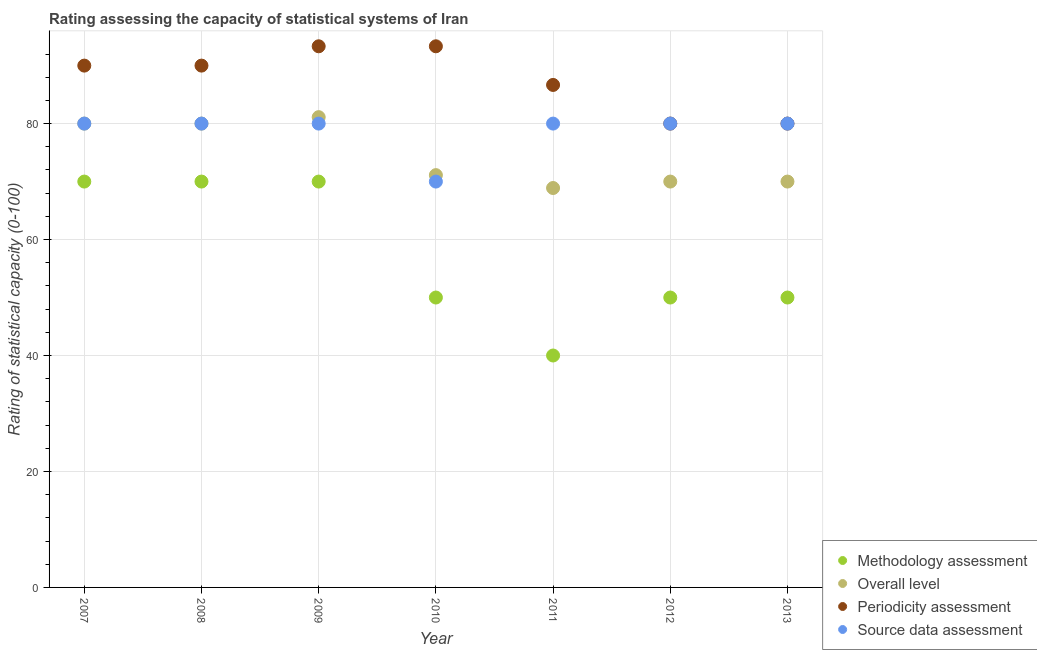How many different coloured dotlines are there?
Provide a succinct answer. 4. Is the number of dotlines equal to the number of legend labels?
Your answer should be very brief. Yes. Across all years, what is the maximum overall level rating?
Your answer should be very brief. 81.11. Across all years, what is the minimum overall level rating?
Make the answer very short. 68.89. In which year was the periodicity assessment rating minimum?
Ensure brevity in your answer.  2012. What is the total methodology assessment rating in the graph?
Provide a short and direct response. 400. What is the difference between the periodicity assessment rating in 2007 and that in 2010?
Give a very brief answer. -3.33. What is the difference between the overall level rating in 2011 and the source data assessment rating in 2008?
Your response must be concise. -11.11. What is the average overall level rating per year?
Offer a terse response. 74.44. In the year 2009, what is the difference between the source data assessment rating and overall level rating?
Your answer should be very brief. -1.11. What is the ratio of the source data assessment rating in 2010 to that in 2011?
Offer a terse response. 0.88. Is the methodology assessment rating in 2009 less than that in 2012?
Keep it short and to the point. No. What is the difference between the highest and the lowest overall level rating?
Your answer should be compact. 12.22. In how many years, is the methodology assessment rating greater than the average methodology assessment rating taken over all years?
Your response must be concise. 3. Is the sum of the periodicity assessment rating in 2008 and 2011 greater than the maximum source data assessment rating across all years?
Your answer should be compact. Yes. Is the overall level rating strictly greater than the source data assessment rating over the years?
Provide a short and direct response. No. Are the values on the major ticks of Y-axis written in scientific E-notation?
Your answer should be compact. No. Does the graph contain grids?
Ensure brevity in your answer.  Yes. How are the legend labels stacked?
Give a very brief answer. Vertical. What is the title of the graph?
Offer a very short reply. Rating assessing the capacity of statistical systems of Iran. Does "Subsidies and Transfers" appear as one of the legend labels in the graph?
Give a very brief answer. No. What is the label or title of the X-axis?
Give a very brief answer. Year. What is the label or title of the Y-axis?
Give a very brief answer. Rating of statistical capacity (0-100). What is the Rating of statistical capacity (0-100) in Periodicity assessment in 2007?
Offer a terse response. 90. What is the Rating of statistical capacity (0-100) of Source data assessment in 2007?
Your response must be concise. 80. What is the Rating of statistical capacity (0-100) of Methodology assessment in 2008?
Your response must be concise. 70. What is the Rating of statistical capacity (0-100) of Methodology assessment in 2009?
Offer a terse response. 70. What is the Rating of statistical capacity (0-100) in Overall level in 2009?
Provide a succinct answer. 81.11. What is the Rating of statistical capacity (0-100) in Periodicity assessment in 2009?
Your answer should be compact. 93.33. What is the Rating of statistical capacity (0-100) in Source data assessment in 2009?
Offer a terse response. 80. What is the Rating of statistical capacity (0-100) in Overall level in 2010?
Offer a very short reply. 71.11. What is the Rating of statistical capacity (0-100) in Periodicity assessment in 2010?
Provide a succinct answer. 93.33. What is the Rating of statistical capacity (0-100) of Source data assessment in 2010?
Your response must be concise. 70. What is the Rating of statistical capacity (0-100) of Methodology assessment in 2011?
Give a very brief answer. 40. What is the Rating of statistical capacity (0-100) of Overall level in 2011?
Offer a terse response. 68.89. What is the Rating of statistical capacity (0-100) of Periodicity assessment in 2011?
Keep it short and to the point. 86.67. What is the Rating of statistical capacity (0-100) in Overall level in 2012?
Your answer should be compact. 70. What is the Rating of statistical capacity (0-100) of Periodicity assessment in 2012?
Your answer should be very brief. 80. What is the Rating of statistical capacity (0-100) of Source data assessment in 2012?
Provide a succinct answer. 80. What is the Rating of statistical capacity (0-100) of Periodicity assessment in 2013?
Your answer should be very brief. 80. What is the Rating of statistical capacity (0-100) of Source data assessment in 2013?
Provide a short and direct response. 80. Across all years, what is the maximum Rating of statistical capacity (0-100) in Overall level?
Ensure brevity in your answer.  81.11. Across all years, what is the maximum Rating of statistical capacity (0-100) in Periodicity assessment?
Make the answer very short. 93.33. Across all years, what is the maximum Rating of statistical capacity (0-100) of Source data assessment?
Provide a short and direct response. 80. Across all years, what is the minimum Rating of statistical capacity (0-100) in Methodology assessment?
Make the answer very short. 40. Across all years, what is the minimum Rating of statistical capacity (0-100) of Overall level?
Your answer should be very brief. 68.89. Across all years, what is the minimum Rating of statistical capacity (0-100) of Periodicity assessment?
Ensure brevity in your answer.  80. What is the total Rating of statistical capacity (0-100) in Methodology assessment in the graph?
Your response must be concise. 400. What is the total Rating of statistical capacity (0-100) of Overall level in the graph?
Your response must be concise. 521.11. What is the total Rating of statistical capacity (0-100) of Periodicity assessment in the graph?
Your answer should be very brief. 613.33. What is the total Rating of statistical capacity (0-100) in Source data assessment in the graph?
Provide a short and direct response. 550. What is the difference between the Rating of statistical capacity (0-100) in Methodology assessment in 2007 and that in 2008?
Offer a terse response. 0. What is the difference between the Rating of statistical capacity (0-100) in Source data assessment in 2007 and that in 2008?
Make the answer very short. 0. What is the difference between the Rating of statistical capacity (0-100) in Overall level in 2007 and that in 2009?
Provide a short and direct response. -1.11. What is the difference between the Rating of statistical capacity (0-100) in Methodology assessment in 2007 and that in 2010?
Make the answer very short. 20. What is the difference between the Rating of statistical capacity (0-100) in Overall level in 2007 and that in 2010?
Offer a terse response. 8.89. What is the difference between the Rating of statistical capacity (0-100) of Periodicity assessment in 2007 and that in 2010?
Your response must be concise. -3.33. What is the difference between the Rating of statistical capacity (0-100) in Source data assessment in 2007 and that in 2010?
Your answer should be compact. 10. What is the difference between the Rating of statistical capacity (0-100) in Overall level in 2007 and that in 2011?
Offer a very short reply. 11.11. What is the difference between the Rating of statistical capacity (0-100) of Periodicity assessment in 2007 and that in 2011?
Provide a short and direct response. 3.33. What is the difference between the Rating of statistical capacity (0-100) in Methodology assessment in 2007 and that in 2012?
Offer a very short reply. 20. What is the difference between the Rating of statistical capacity (0-100) of Periodicity assessment in 2007 and that in 2012?
Ensure brevity in your answer.  10. What is the difference between the Rating of statistical capacity (0-100) of Source data assessment in 2007 and that in 2012?
Your response must be concise. 0. What is the difference between the Rating of statistical capacity (0-100) of Overall level in 2007 and that in 2013?
Provide a short and direct response. 10. What is the difference between the Rating of statistical capacity (0-100) of Source data assessment in 2007 and that in 2013?
Your response must be concise. 0. What is the difference between the Rating of statistical capacity (0-100) of Methodology assessment in 2008 and that in 2009?
Provide a succinct answer. 0. What is the difference between the Rating of statistical capacity (0-100) in Overall level in 2008 and that in 2009?
Your response must be concise. -1.11. What is the difference between the Rating of statistical capacity (0-100) of Periodicity assessment in 2008 and that in 2009?
Your answer should be compact. -3.33. What is the difference between the Rating of statistical capacity (0-100) in Source data assessment in 2008 and that in 2009?
Ensure brevity in your answer.  0. What is the difference between the Rating of statistical capacity (0-100) in Methodology assessment in 2008 and that in 2010?
Provide a succinct answer. 20. What is the difference between the Rating of statistical capacity (0-100) of Overall level in 2008 and that in 2010?
Ensure brevity in your answer.  8.89. What is the difference between the Rating of statistical capacity (0-100) in Periodicity assessment in 2008 and that in 2010?
Your response must be concise. -3.33. What is the difference between the Rating of statistical capacity (0-100) in Source data assessment in 2008 and that in 2010?
Your response must be concise. 10. What is the difference between the Rating of statistical capacity (0-100) of Methodology assessment in 2008 and that in 2011?
Make the answer very short. 30. What is the difference between the Rating of statistical capacity (0-100) in Overall level in 2008 and that in 2011?
Give a very brief answer. 11.11. What is the difference between the Rating of statistical capacity (0-100) in Source data assessment in 2008 and that in 2011?
Your answer should be very brief. 0. What is the difference between the Rating of statistical capacity (0-100) of Overall level in 2008 and that in 2012?
Ensure brevity in your answer.  10. What is the difference between the Rating of statistical capacity (0-100) of Source data assessment in 2008 and that in 2012?
Ensure brevity in your answer.  0. What is the difference between the Rating of statistical capacity (0-100) in Periodicity assessment in 2008 and that in 2013?
Keep it short and to the point. 10. What is the difference between the Rating of statistical capacity (0-100) of Source data assessment in 2008 and that in 2013?
Keep it short and to the point. 0. What is the difference between the Rating of statistical capacity (0-100) in Methodology assessment in 2009 and that in 2010?
Your response must be concise. 20. What is the difference between the Rating of statistical capacity (0-100) in Overall level in 2009 and that in 2010?
Provide a short and direct response. 10. What is the difference between the Rating of statistical capacity (0-100) in Periodicity assessment in 2009 and that in 2010?
Ensure brevity in your answer.  0. What is the difference between the Rating of statistical capacity (0-100) in Methodology assessment in 2009 and that in 2011?
Give a very brief answer. 30. What is the difference between the Rating of statistical capacity (0-100) in Overall level in 2009 and that in 2011?
Your answer should be compact. 12.22. What is the difference between the Rating of statistical capacity (0-100) in Periodicity assessment in 2009 and that in 2011?
Make the answer very short. 6.67. What is the difference between the Rating of statistical capacity (0-100) of Overall level in 2009 and that in 2012?
Your answer should be very brief. 11.11. What is the difference between the Rating of statistical capacity (0-100) in Periodicity assessment in 2009 and that in 2012?
Your answer should be very brief. 13.33. What is the difference between the Rating of statistical capacity (0-100) of Methodology assessment in 2009 and that in 2013?
Provide a short and direct response. 20. What is the difference between the Rating of statistical capacity (0-100) of Overall level in 2009 and that in 2013?
Provide a short and direct response. 11.11. What is the difference between the Rating of statistical capacity (0-100) of Periodicity assessment in 2009 and that in 2013?
Your answer should be compact. 13.33. What is the difference between the Rating of statistical capacity (0-100) in Methodology assessment in 2010 and that in 2011?
Provide a short and direct response. 10. What is the difference between the Rating of statistical capacity (0-100) in Overall level in 2010 and that in 2011?
Your response must be concise. 2.22. What is the difference between the Rating of statistical capacity (0-100) in Source data assessment in 2010 and that in 2011?
Ensure brevity in your answer.  -10. What is the difference between the Rating of statistical capacity (0-100) of Overall level in 2010 and that in 2012?
Make the answer very short. 1.11. What is the difference between the Rating of statistical capacity (0-100) in Periodicity assessment in 2010 and that in 2012?
Your response must be concise. 13.33. What is the difference between the Rating of statistical capacity (0-100) of Overall level in 2010 and that in 2013?
Offer a terse response. 1.11. What is the difference between the Rating of statistical capacity (0-100) of Periodicity assessment in 2010 and that in 2013?
Ensure brevity in your answer.  13.33. What is the difference between the Rating of statistical capacity (0-100) in Source data assessment in 2010 and that in 2013?
Your answer should be very brief. -10. What is the difference between the Rating of statistical capacity (0-100) of Methodology assessment in 2011 and that in 2012?
Ensure brevity in your answer.  -10. What is the difference between the Rating of statistical capacity (0-100) in Overall level in 2011 and that in 2012?
Provide a short and direct response. -1.11. What is the difference between the Rating of statistical capacity (0-100) in Methodology assessment in 2011 and that in 2013?
Your answer should be compact. -10. What is the difference between the Rating of statistical capacity (0-100) in Overall level in 2011 and that in 2013?
Give a very brief answer. -1.11. What is the difference between the Rating of statistical capacity (0-100) of Source data assessment in 2012 and that in 2013?
Provide a succinct answer. 0. What is the difference between the Rating of statistical capacity (0-100) of Methodology assessment in 2007 and the Rating of statistical capacity (0-100) of Overall level in 2008?
Provide a short and direct response. -10. What is the difference between the Rating of statistical capacity (0-100) in Methodology assessment in 2007 and the Rating of statistical capacity (0-100) in Periodicity assessment in 2008?
Offer a terse response. -20. What is the difference between the Rating of statistical capacity (0-100) in Methodology assessment in 2007 and the Rating of statistical capacity (0-100) in Source data assessment in 2008?
Make the answer very short. -10. What is the difference between the Rating of statistical capacity (0-100) of Overall level in 2007 and the Rating of statistical capacity (0-100) of Periodicity assessment in 2008?
Ensure brevity in your answer.  -10. What is the difference between the Rating of statistical capacity (0-100) in Methodology assessment in 2007 and the Rating of statistical capacity (0-100) in Overall level in 2009?
Your answer should be very brief. -11.11. What is the difference between the Rating of statistical capacity (0-100) in Methodology assessment in 2007 and the Rating of statistical capacity (0-100) in Periodicity assessment in 2009?
Provide a succinct answer. -23.33. What is the difference between the Rating of statistical capacity (0-100) of Overall level in 2007 and the Rating of statistical capacity (0-100) of Periodicity assessment in 2009?
Provide a short and direct response. -13.33. What is the difference between the Rating of statistical capacity (0-100) in Overall level in 2007 and the Rating of statistical capacity (0-100) in Source data assessment in 2009?
Provide a succinct answer. 0. What is the difference between the Rating of statistical capacity (0-100) of Methodology assessment in 2007 and the Rating of statistical capacity (0-100) of Overall level in 2010?
Ensure brevity in your answer.  -1.11. What is the difference between the Rating of statistical capacity (0-100) of Methodology assessment in 2007 and the Rating of statistical capacity (0-100) of Periodicity assessment in 2010?
Your answer should be very brief. -23.33. What is the difference between the Rating of statistical capacity (0-100) in Overall level in 2007 and the Rating of statistical capacity (0-100) in Periodicity assessment in 2010?
Your response must be concise. -13.33. What is the difference between the Rating of statistical capacity (0-100) of Periodicity assessment in 2007 and the Rating of statistical capacity (0-100) of Source data assessment in 2010?
Keep it short and to the point. 20. What is the difference between the Rating of statistical capacity (0-100) of Methodology assessment in 2007 and the Rating of statistical capacity (0-100) of Overall level in 2011?
Your response must be concise. 1.11. What is the difference between the Rating of statistical capacity (0-100) of Methodology assessment in 2007 and the Rating of statistical capacity (0-100) of Periodicity assessment in 2011?
Keep it short and to the point. -16.67. What is the difference between the Rating of statistical capacity (0-100) of Methodology assessment in 2007 and the Rating of statistical capacity (0-100) of Source data assessment in 2011?
Offer a terse response. -10. What is the difference between the Rating of statistical capacity (0-100) of Overall level in 2007 and the Rating of statistical capacity (0-100) of Periodicity assessment in 2011?
Ensure brevity in your answer.  -6.67. What is the difference between the Rating of statistical capacity (0-100) of Overall level in 2007 and the Rating of statistical capacity (0-100) of Source data assessment in 2011?
Provide a short and direct response. 0. What is the difference between the Rating of statistical capacity (0-100) in Methodology assessment in 2007 and the Rating of statistical capacity (0-100) in Source data assessment in 2012?
Make the answer very short. -10. What is the difference between the Rating of statistical capacity (0-100) of Overall level in 2007 and the Rating of statistical capacity (0-100) of Periodicity assessment in 2012?
Your response must be concise. 0. What is the difference between the Rating of statistical capacity (0-100) of Overall level in 2007 and the Rating of statistical capacity (0-100) of Source data assessment in 2012?
Your answer should be very brief. 0. What is the difference between the Rating of statistical capacity (0-100) of Overall level in 2007 and the Rating of statistical capacity (0-100) of Periodicity assessment in 2013?
Your answer should be very brief. 0. What is the difference between the Rating of statistical capacity (0-100) in Overall level in 2007 and the Rating of statistical capacity (0-100) in Source data assessment in 2013?
Ensure brevity in your answer.  0. What is the difference between the Rating of statistical capacity (0-100) in Methodology assessment in 2008 and the Rating of statistical capacity (0-100) in Overall level in 2009?
Keep it short and to the point. -11.11. What is the difference between the Rating of statistical capacity (0-100) of Methodology assessment in 2008 and the Rating of statistical capacity (0-100) of Periodicity assessment in 2009?
Your answer should be compact. -23.33. What is the difference between the Rating of statistical capacity (0-100) of Overall level in 2008 and the Rating of statistical capacity (0-100) of Periodicity assessment in 2009?
Ensure brevity in your answer.  -13.33. What is the difference between the Rating of statistical capacity (0-100) in Periodicity assessment in 2008 and the Rating of statistical capacity (0-100) in Source data assessment in 2009?
Provide a short and direct response. 10. What is the difference between the Rating of statistical capacity (0-100) of Methodology assessment in 2008 and the Rating of statistical capacity (0-100) of Overall level in 2010?
Make the answer very short. -1.11. What is the difference between the Rating of statistical capacity (0-100) in Methodology assessment in 2008 and the Rating of statistical capacity (0-100) in Periodicity assessment in 2010?
Your response must be concise. -23.33. What is the difference between the Rating of statistical capacity (0-100) of Methodology assessment in 2008 and the Rating of statistical capacity (0-100) of Source data assessment in 2010?
Offer a very short reply. 0. What is the difference between the Rating of statistical capacity (0-100) in Overall level in 2008 and the Rating of statistical capacity (0-100) in Periodicity assessment in 2010?
Provide a short and direct response. -13.33. What is the difference between the Rating of statistical capacity (0-100) of Methodology assessment in 2008 and the Rating of statistical capacity (0-100) of Overall level in 2011?
Offer a terse response. 1.11. What is the difference between the Rating of statistical capacity (0-100) in Methodology assessment in 2008 and the Rating of statistical capacity (0-100) in Periodicity assessment in 2011?
Your answer should be very brief. -16.67. What is the difference between the Rating of statistical capacity (0-100) in Methodology assessment in 2008 and the Rating of statistical capacity (0-100) in Source data assessment in 2011?
Your answer should be very brief. -10. What is the difference between the Rating of statistical capacity (0-100) of Overall level in 2008 and the Rating of statistical capacity (0-100) of Periodicity assessment in 2011?
Ensure brevity in your answer.  -6.67. What is the difference between the Rating of statistical capacity (0-100) of Overall level in 2008 and the Rating of statistical capacity (0-100) of Source data assessment in 2011?
Provide a short and direct response. 0. What is the difference between the Rating of statistical capacity (0-100) of Periodicity assessment in 2008 and the Rating of statistical capacity (0-100) of Source data assessment in 2011?
Your answer should be very brief. 10. What is the difference between the Rating of statistical capacity (0-100) of Methodology assessment in 2008 and the Rating of statistical capacity (0-100) of Overall level in 2012?
Offer a terse response. 0. What is the difference between the Rating of statistical capacity (0-100) in Methodology assessment in 2008 and the Rating of statistical capacity (0-100) in Periodicity assessment in 2012?
Your answer should be compact. -10. What is the difference between the Rating of statistical capacity (0-100) in Overall level in 2008 and the Rating of statistical capacity (0-100) in Periodicity assessment in 2012?
Your response must be concise. 0. What is the difference between the Rating of statistical capacity (0-100) of Overall level in 2008 and the Rating of statistical capacity (0-100) of Source data assessment in 2012?
Give a very brief answer. 0. What is the difference between the Rating of statistical capacity (0-100) of Methodology assessment in 2008 and the Rating of statistical capacity (0-100) of Overall level in 2013?
Give a very brief answer. 0. What is the difference between the Rating of statistical capacity (0-100) in Overall level in 2008 and the Rating of statistical capacity (0-100) in Periodicity assessment in 2013?
Provide a succinct answer. 0. What is the difference between the Rating of statistical capacity (0-100) of Methodology assessment in 2009 and the Rating of statistical capacity (0-100) of Overall level in 2010?
Make the answer very short. -1.11. What is the difference between the Rating of statistical capacity (0-100) of Methodology assessment in 2009 and the Rating of statistical capacity (0-100) of Periodicity assessment in 2010?
Keep it short and to the point. -23.33. What is the difference between the Rating of statistical capacity (0-100) of Overall level in 2009 and the Rating of statistical capacity (0-100) of Periodicity assessment in 2010?
Your answer should be compact. -12.22. What is the difference between the Rating of statistical capacity (0-100) in Overall level in 2009 and the Rating of statistical capacity (0-100) in Source data assessment in 2010?
Keep it short and to the point. 11.11. What is the difference between the Rating of statistical capacity (0-100) in Periodicity assessment in 2009 and the Rating of statistical capacity (0-100) in Source data assessment in 2010?
Provide a succinct answer. 23.33. What is the difference between the Rating of statistical capacity (0-100) of Methodology assessment in 2009 and the Rating of statistical capacity (0-100) of Periodicity assessment in 2011?
Your answer should be compact. -16.67. What is the difference between the Rating of statistical capacity (0-100) of Methodology assessment in 2009 and the Rating of statistical capacity (0-100) of Source data assessment in 2011?
Provide a succinct answer. -10. What is the difference between the Rating of statistical capacity (0-100) in Overall level in 2009 and the Rating of statistical capacity (0-100) in Periodicity assessment in 2011?
Offer a very short reply. -5.56. What is the difference between the Rating of statistical capacity (0-100) in Overall level in 2009 and the Rating of statistical capacity (0-100) in Source data assessment in 2011?
Keep it short and to the point. 1.11. What is the difference between the Rating of statistical capacity (0-100) in Periodicity assessment in 2009 and the Rating of statistical capacity (0-100) in Source data assessment in 2011?
Keep it short and to the point. 13.33. What is the difference between the Rating of statistical capacity (0-100) of Methodology assessment in 2009 and the Rating of statistical capacity (0-100) of Overall level in 2012?
Keep it short and to the point. 0. What is the difference between the Rating of statistical capacity (0-100) in Overall level in 2009 and the Rating of statistical capacity (0-100) in Periodicity assessment in 2012?
Give a very brief answer. 1.11. What is the difference between the Rating of statistical capacity (0-100) in Periodicity assessment in 2009 and the Rating of statistical capacity (0-100) in Source data assessment in 2012?
Provide a short and direct response. 13.33. What is the difference between the Rating of statistical capacity (0-100) in Methodology assessment in 2009 and the Rating of statistical capacity (0-100) in Source data assessment in 2013?
Your response must be concise. -10. What is the difference between the Rating of statistical capacity (0-100) in Periodicity assessment in 2009 and the Rating of statistical capacity (0-100) in Source data assessment in 2013?
Your answer should be compact. 13.33. What is the difference between the Rating of statistical capacity (0-100) of Methodology assessment in 2010 and the Rating of statistical capacity (0-100) of Overall level in 2011?
Your response must be concise. -18.89. What is the difference between the Rating of statistical capacity (0-100) of Methodology assessment in 2010 and the Rating of statistical capacity (0-100) of Periodicity assessment in 2011?
Ensure brevity in your answer.  -36.67. What is the difference between the Rating of statistical capacity (0-100) of Methodology assessment in 2010 and the Rating of statistical capacity (0-100) of Source data assessment in 2011?
Offer a terse response. -30. What is the difference between the Rating of statistical capacity (0-100) in Overall level in 2010 and the Rating of statistical capacity (0-100) in Periodicity assessment in 2011?
Provide a succinct answer. -15.56. What is the difference between the Rating of statistical capacity (0-100) in Overall level in 2010 and the Rating of statistical capacity (0-100) in Source data assessment in 2011?
Ensure brevity in your answer.  -8.89. What is the difference between the Rating of statistical capacity (0-100) in Periodicity assessment in 2010 and the Rating of statistical capacity (0-100) in Source data assessment in 2011?
Offer a terse response. 13.33. What is the difference between the Rating of statistical capacity (0-100) of Methodology assessment in 2010 and the Rating of statistical capacity (0-100) of Overall level in 2012?
Offer a very short reply. -20. What is the difference between the Rating of statistical capacity (0-100) in Methodology assessment in 2010 and the Rating of statistical capacity (0-100) in Periodicity assessment in 2012?
Give a very brief answer. -30. What is the difference between the Rating of statistical capacity (0-100) in Overall level in 2010 and the Rating of statistical capacity (0-100) in Periodicity assessment in 2012?
Offer a terse response. -8.89. What is the difference between the Rating of statistical capacity (0-100) in Overall level in 2010 and the Rating of statistical capacity (0-100) in Source data assessment in 2012?
Offer a very short reply. -8.89. What is the difference between the Rating of statistical capacity (0-100) of Periodicity assessment in 2010 and the Rating of statistical capacity (0-100) of Source data assessment in 2012?
Your response must be concise. 13.33. What is the difference between the Rating of statistical capacity (0-100) in Methodology assessment in 2010 and the Rating of statistical capacity (0-100) in Overall level in 2013?
Provide a short and direct response. -20. What is the difference between the Rating of statistical capacity (0-100) of Methodology assessment in 2010 and the Rating of statistical capacity (0-100) of Periodicity assessment in 2013?
Give a very brief answer. -30. What is the difference between the Rating of statistical capacity (0-100) in Overall level in 2010 and the Rating of statistical capacity (0-100) in Periodicity assessment in 2013?
Provide a succinct answer. -8.89. What is the difference between the Rating of statistical capacity (0-100) in Overall level in 2010 and the Rating of statistical capacity (0-100) in Source data assessment in 2013?
Your answer should be compact. -8.89. What is the difference between the Rating of statistical capacity (0-100) in Periodicity assessment in 2010 and the Rating of statistical capacity (0-100) in Source data assessment in 2013?
Offer a terse response. 13.33. What is the difference between the Rating of statistical capacity (0-100) in Methodology assessment in 2011 and the Rating of statistical capacity (0-100) in Periodicity assessment in 2012?
Offer a very short reply. -40. What is the difference between the Rating of statistical capacity (0-100) in Methodology assessment in 2011 and the Rating of statistical capacity (0-100) in Source data assessment in 2012?
Offer a very short reply. -40. What is the difference between the Rating of statistical capacity (0-100) of Overall level in 2011 and the Rating of statistical capacity (0-100) of Periodicity assessment in 2012?
Your response must be concise. -11.11. What is the difference between the Rating of statistical capacity (0-100) of Overall level in 2011 and the Rating of statistical capacity (0-100) of Source data assessment in 2012?
Give a very brief answer. -11.11. What is the difference between the Rating of statistical capacity (0-100) of Methodology assessment in 2011 and the Rating of statistical capacity (0-100) of Periodicity assessment in 2013?
Ensure brevity in your answer.  -40. What is the difference between the Rating of statistical capacity (0-100) in Overall level in 2011 and the Rating of statistical capacity (0-100) in Periodicity assessment in 2013?
Provide a succinct answer. -11.11. What is the difference between the Rating of statistical capacity (0-100) in Overall level in 2011 and the Rating of statistical capacity (0-100) in Source data assessment in 2013?
Give a very brief answer. -11.11. What is the difference between the Rating of statistical capacity (0-100) in Methodology assessment in 2012 and the Rating of statistical capacity (0-100) in Periodicity assessment in 2013?
Offer a very short reply. -30. What is the difference between the Rating of statistical capacity (0-100) in Overall level in 2012 and the Rating of statistical capacity (0-100) in Periodicity assessment in 2013?
Make the answer very short. -10. What is the difference between the Rating of statistical capacity (0-100) of Periodicity assessment in 2012 and the Rating of statistical capacity (0-100) of Source data assessment in 2013?
Make the answer very short. 0. What is the average Rating of statistical capacity (0-100) of Methodology assessment per year?
Provide a short and direct response. 57.14. What is the average Rating of statistical capacity (0-100) of Overall level per year?
Ensure brevity in your answer.  74.44. What is the average Rating of statistical capacity (0-100) in Periodicity assessment per year?
Offer a terse response. 87.62. What is the average Rating of statistical capacity (0-100) of Source data assessment per year?
Ensure brevity in your answer.  78.57. In the year 2007, what is the difference between the Rating of statistical capacity (0-100) of Methodology assessment and Rating of statistical capacity (0-100) of Overall level?
Offer a terse response. -10. In the year 2007, what is the difference between the Rating of statistical capacity (0-100) in Methodology assessment and Rating of statistical capacity (0-100) in Source data assessment?
Provide a succinct answer. -10. In the year 2007, what is the difference between the Rating of statistical capacity (0-100) of Overall level and Rating of statistical capacity (0-100) of Source data assessment?
Offer a very short reply. 0. In the year 2008, what is the difference between the Rating of statistical capacity (0-100) of Methodology assessment and Rating of statistical capacity (0-100) of Overall level?
Your answer should be very brief. -10. In the year 2009, what is the difference between the Rating of statistical capacity (0-100) in Methodology assessment and Rating of statistical capacity (0-100) in Overall level?
Offer a very short reply. -11.11. In the year 2009, what is the difference between the Rating of statistical capacity (0-100) of Methodology assessment and Rating of statistical capacity (0-100) of Periodicity assessment?
Your answer should be compact. -23.33. In the year 2009, what is the difference between the Rating of statistical capacity (0-100) of Overall level and Rating of statistical capacity (0-100) of Periodicity assessment?
Your response must be concise. -12.22. In the year 2009, what is the difference between the Rating of statistical capacity (0-100) in Overall level and Rating of statistical capacity (0-100) in Source data assessment?
Offer a terse response. 1.11. In the year 2009, what is the difference between the Rating of statistical capacity (0-100) in Periodicity assessment and Rating of statistical capacity (0-100) in Source data assessment?
Your answer should be very brief. 13.33. In the year 2010, what is the difference between the Rating of statistical capacity (0-100) in Methodology assessment and Rating of statistical capacity (0-100) in Overall level?
Your response must be concise. -21.11. In the year 2010, what is the difference between the Rating of statistical capacity (0-100) of Methodology assessment and Rating of statistical capacity (0-100) of Periodicity assessment?
Give a very brief answer. -43.33. In the year 2010, what is the difference between the Rating of statistical capacity (0-100) in Methodology assessment and Rating of statistical capacity (0-100) in Source data assessment?
Keep it short and to the point. -20. In the year 2010, what is the difference between the Rating of statistical capacity (0-100) in Overall level and Rating of statistical capacity (0-100) in Periodicity assessment?
Keep it short and to the point. -22.22. In the year 2010, what is the difference between the Rating of statistical capacity (0-100) of Periodicity assessment and Rating of statistical capacity (0-100) of Source data assessment?
Provide a short and direct response. 23.33. In the year 2011, what is the difference between the Rating of statistical capacity (0-100) of Methodology assessment and Rating of statistical capacity (0-100) of Overall level?
Ensure brevity in your answer.  -28.89. In the year 2011, what is the difference between the Rating of statistical capacity (0-100) of Methodology assessment and Rating of statistical capacity (0-100) of Periodicity assessment?
Offer a very short reply. -46.67. In the year 2011, what is the difference between the Rating of statistical capacity (0-100) of Overall level and Rating of statistical capacity (0-100) of Periodicity assessment?
Give a very brief answer. -17.78. In the year 2011, what is the difference between the Rating of statistical capacity (0-100) in Overall level and Rating of statistical capacity (0-100) in Source data assessment?
Ensure brevity in your answer.  -11.11. In the year 2012, what is the difference between the Rating of statistical capacity (0-100) in Overall level and Rating of statistical capacity (0-100) in Periodicity assessment?
Ensure brevity in your answer.  -10. In the year 2012, what is the difference between the Rating of statistical capacity (0-100) of Overall level and Rating of statistical capacity (0-100) of Source data assessment?
Offer a very short reply. -10. In the year 2013, what is the difference between the Rating of statistical capacity (0-100) in Methodology assessment and Rating of statistical capacity (0-100) in Overall level?
Offer a very short reply. -20. In the year 2013, what is the difference between the Rating of statistical capacity (0-100) in Methodology assessment and Rating of statistical capacity (0-100) in Periodicity assessment?
Provide a short and direct response. -30. In the year 2013, what is the difference between the Rating of statistical capacity (0-100) of Overall level and Rating of statistical capacity (0-100) of Source data assessment?
Provide a short and direct response. -10. What is the ratio of the Rating of statistical capacity (0-100) in Periodicity assessment in 2007 to that in 2008?
Give a very brief answer. 1. What is the ratio of the Rating of statistical capacity (0-100) of Methodology assessment in 2007 to that in 2009?
Your answer should be compact. 1. What is the ratio of the Rating of statistical capacity (0-100) of Overall level in 2007 to that in 2009?
Ensure brevity in your answer.  0.99. What is the ratio of the Rating of statistical capacity (0-100) of Source data assessment in 2007 to that in 2009?
Your answer should be very brief. 1. What is the ratio of the Rating of statistical capacity (0-100) in Source data assessment in 2007 to that in 2010?
Ensure brevity in your answer.  1.14. What is the ratio of the Rating of statistical capacity (0-100) in Overall level in 2007 to that in 2011?
Ensure brevity in your answer.  1.16. What is the ratio of the Rating of statistical capacity (0-100) in Methodology assessment in 2007 to that in 2012?
Ensure brevity in your answer.  1.4. What is the ratio of the Rating of statistical capacity (0-100) in Overall level in 2007 to that in 2012?
Keep it short and to the point. 1.14. What is the ratio of the Rating of statistical capacity (0-100) in Periodicity assessment in 2007 to that in 2012?
Ensure brevity in your answer.  1.12. What is the ratio of the Rating of statistical capacity (0-100) in Methodology assessment in 2007 to that in 2013?
Offer a terse response. 1.4. What is the ratio of the Rating of statistical capacity (0-100) in Overall level in 2007 to that in 2013?
Give a very brief answer. 1.14. What is the ratio of the Rating of statistical capacity (0-100) in Periodicity assessment in 2007 to that in 2013?
Offer a very short reply. 1.12. What is the ratio of the Rating of statistical capacity (0-100) in Source data assessment in 2007 to that in 2013?
Offer a very short reply. 1. What is the ratio of the Rating of statistical capacity (0-100) in Methodology assessment in 2008 to that in 2009?
Provide a short and direct response. 1. What is the ratio of the Rating of statistical capacity (0-100) of Overall level in 2008 to that in 2009?
Make the answer very short. 0.99. What is the ratio of the Rating of statistical capacity (0-100) of Methodology assessment in 2008 to that in 2010?
Offer a very short reply. 1.4. What is the ratio of the Rating of statistical capacity (0-100) in Periodicity assessment in 2008 to that in 2010?
Give a very brief answer. 0.96. What is the ratio of the Rating of statistical capacity (0-100) of Source data assessment in 2008 to that in 2010?
Ensure brevity in your answer.  1.14. What is the ratio of the Rating of statistical capacity (0-100) of Overall level in 2008 to that in 2011?
Your response must be concise. 1.16. What is the ratio of the Rating of statistical capacity (0-100) of Methodology assessment in 2008 to that in 2012?
Your answer should be compact. 1.4. What is the ratio of the Rating of statistical capacity (0-100) in Methodology assessment in 2008 to that in 2013?
Your answer should be compact. 1.4. What is the ratio of the Rating of statistical capacity (0-100) of Overall level in 2008 to that in 2013?
Provide a succinct answer. 1.14. What is the ratio of the Rating of statistical capacity (0-100) in Overall level in 2009 to that in 2010?
Your answer should be very brief. 1.14. What is the ratio of the Rating of statistical capacity (0-100) in Source data assessment in 2009 to that in 2010?
Your answer should be compact. 1.14. What is the ratio of the Rating of statistical capacity (0-100) of Methodology assessment in 2009 to that in 2011?
Offer a terse response. 1.75. What is the ratio of the Rating of statistical capacity (0-100) of Overall level in 2009 to that in 2011?
Provide a short and direct response. 1.18. What is the ratio of the Rating of statistical capacity (0-100) of Periodicity assessment in 2009 to that in 2011?
Give a very brief answer. 1.08. What is the ratio of the Rating of statistical capacity (0-100) in Overall level in 2009 to that in 2012?
Ensure brevity in your answer.  1.16. What is the ratio of the Rating of statistical capacity (0-100) in Methodology assessment in 2009 to that in 2013?
Your response must be concise. 1.4. What is the ratio of the Rating of statistical capacity (0-100) of Overall level in 2009 to that in 2013?
Give a very brief answer. 1.16. What is the ratio of the Rating of statistical capacity (0-100) of Overall level in 2010 to that in 2011?
Provide a succinct answer. 1.03. What is the ratio of the Rating of statistical capacity (0-100) of Source data assessment in 2010 to that in 2011?
Provide a short and direct response. 0.88. What is the ratio of the Rating of statistical capacity (0-100) of Overall level in 2010 to that in 2012?
Offer a terse response. 1.02. What is the ratio of the Rating of statistical capacity (0-100) in Methodology assessment in 2010 to that in 2013?
Your answer should be very brief. 1. What is the ratio of the Rating of statistical capacity (0-100) of Overall level in 2010 to that in 2013?
Your response must be concise. 1.02. What is the ratio of the Rating of statistical capacity (0-100) in Methodology assessment in 2011 to that in 2012?
Offer a terse response. 0.8. What is the ratio of the Rating of statistical capacity (0-100) in Overall level in 2011 to that in 2012?
Offer a terse response. 0.98. What is the ratio of the Rating of statistical capacity (0-100) in Source data assessment in 2011 to that in 2012?
Give a very brief answer. 1. What is the ratio of the Rating of statistical capacity (0-100) in Overall level in 2011 to that in 2013?
Provide a short and direct response. 0.98. What is the ratio of the Rating of statistical capacity (0-100) of Periodicity assessment in 2012 to that in 2013?
Offer a very short reply. 1. What is the ratio of the Rating of statistical capacity (0-100) in Source data assessment in 2012 to that in 2013?
Ensure brevity in your answer.  1. What is the difference between the highest and the second highest Rating of statistical capacity (0-100) of Periodicity assessment?
Your answer should be compact. 0. What is the difference between the highest and the lowest Rating of statistical capacity (0-100) in Overall level?
Keep it short and to the point. 12.22. What is the difference between the highest and the lowest Rating of statistical capacity (0-100) of Periodicity assessment?
Provide a short and direct response. 13.33. What is the difference between the highest and the lowest Rating of statistical capacity (0-100) of Source data assessment?
Provide a short and direct response. 10. 